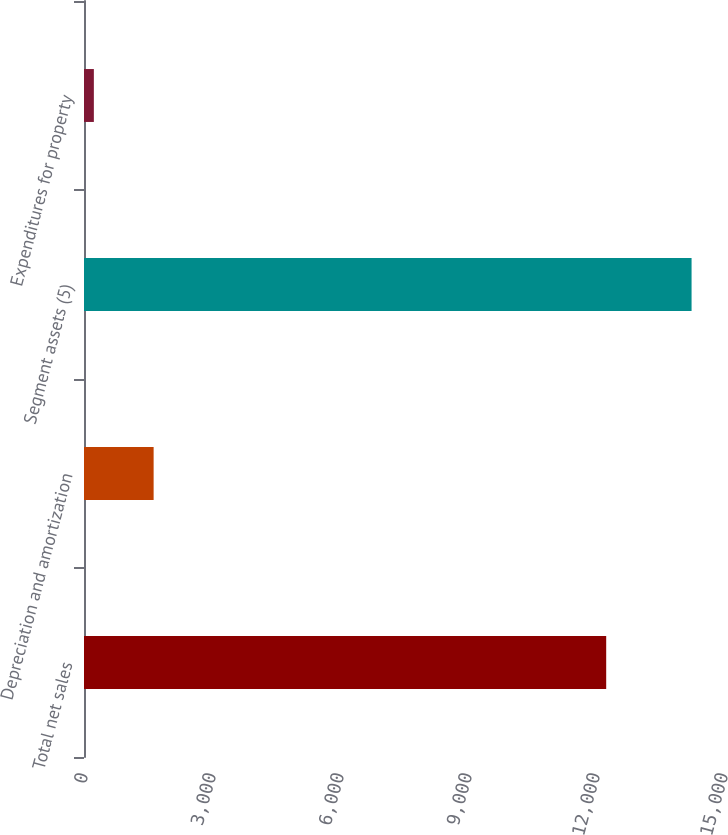Convert chart to OTSL. <chart><loc_0><loc_0><loc_500><loc_500><bar_chart><fcel>Total net sales<fcel>Depreciation and amortization<fcel>Segment assets (5)<fcel>Expenditures for property<nl><fcel>12239<fcel>1631.9<fcel>14240<fcel>231<nl></chart> 